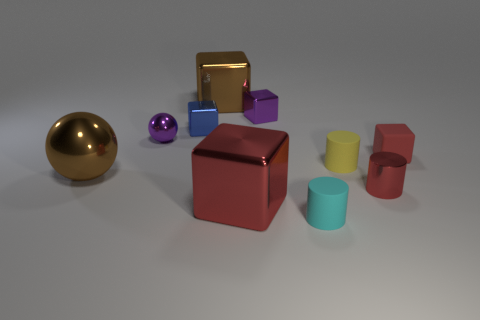Is the small rubber block the same color as the small shiny cylinder?
Your answer should be compact. Yes. Is the color of the large block in front of the tiny rubber cube the same as the shiny cylinder?
Offer a terse response. Yes. What is the material of the red object that is on the left side of the cylinder to the left of the rubber cylinder behind the small cyan object?
Make the answer very short. Metal. What is the color of the other metallic object that is the same shape as the yellow thing?
Your answer should be very brief. Red. There is a metal object that is on the right side of the small cyan object; is it the same color as the tiny rubber cylinder behind the big red metal block?
Give a very brief answer. No. Is the number of red things to the left of the small red shiny object greater than the number of gray matte cubes?
Make the answer very short. Yes. What number of other things are there of the same size as the purple sphere?
Your answer should be very brief. 6. What number of things are both on the left side of the small blue object and right of the tiny metal cylinder?
Offer a terse response. 0. Are the red block that is right of the cyan thing and the small red cylinder made of the same material?
Your response must be concise. No. What is the shape of the brown thing in front of the red thing behind the small rubber cylinder behind the cyan rubber cylinder?
Give a very brief answer. Sphere. 